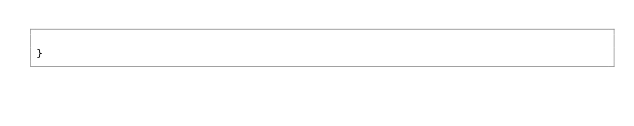Convert code to text. <code><loc_0><loc_0><loc_500><loc_500><_PHP_>    
}
</code> 